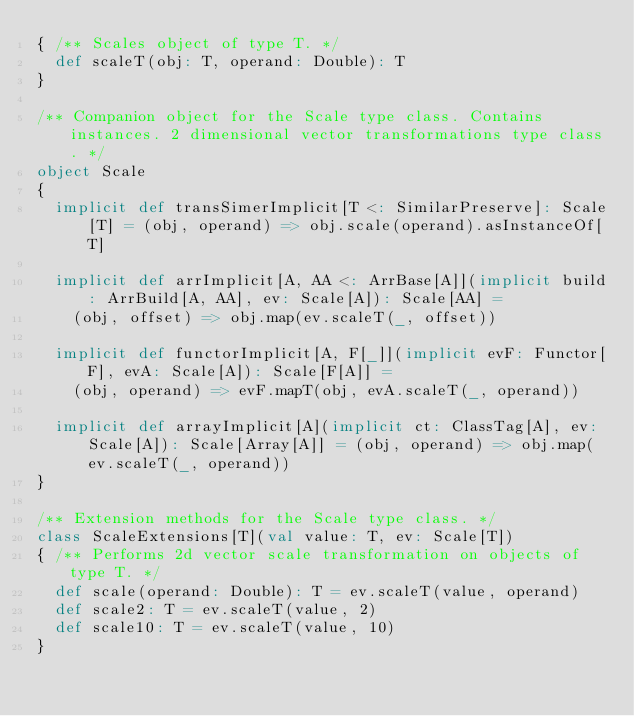Convert code to text. <code><loc_0><loc_0><loc_500><loc_500><_Scala_>{ /** Scales object of type T. */
  def scaleT(obj: T, operand: Double): T
}

/** Companion object for the Scale type class. Contains instances. 2 dimensional vector transformations type class. */
object Scale
{
  implicit def transSimerImplicit[T <: SimilarPreserve]: Scale[T] = (obj, operand) => obj.scale(operand).asInstanceOf[T]

  implicit def arrImplicit[A, AA <: ArrBase[A]](implicit build: ArrBuild[A, AA], ev: Scale[A]): Scale[AA] =
    (obj, offset) => obj.map(ev.scaleT(_, offset))

  implicit def functorImplicit[A, F[_]](implicit evF: Functor[F], evA: Scale[A]): Scale[F[A]] =
    (obj, operand) => evF.mapT(obj, evA.scaleT(_, operand))

  implicit def arrayImplicit[A](implicit ct: ClassTag[A], ev: Scale[A]): Scale[Array[A]] = (obj, operand) => obj.map(ev.scaleT(_, operand))
}

/** Extension methods for the Scale type class. */
class ScaleExtensions[T](val value: T, ev: Scale[T])
{ /** Performs 2d vector scale transformation on objects of type T. */
  def scale(operand: Double): T = ev.scaleT(value, operand)
  def scale2: T = ev.scaleT(value, 2)
  def scale10: T = ev.scaleT(value, 10)
}</code> 